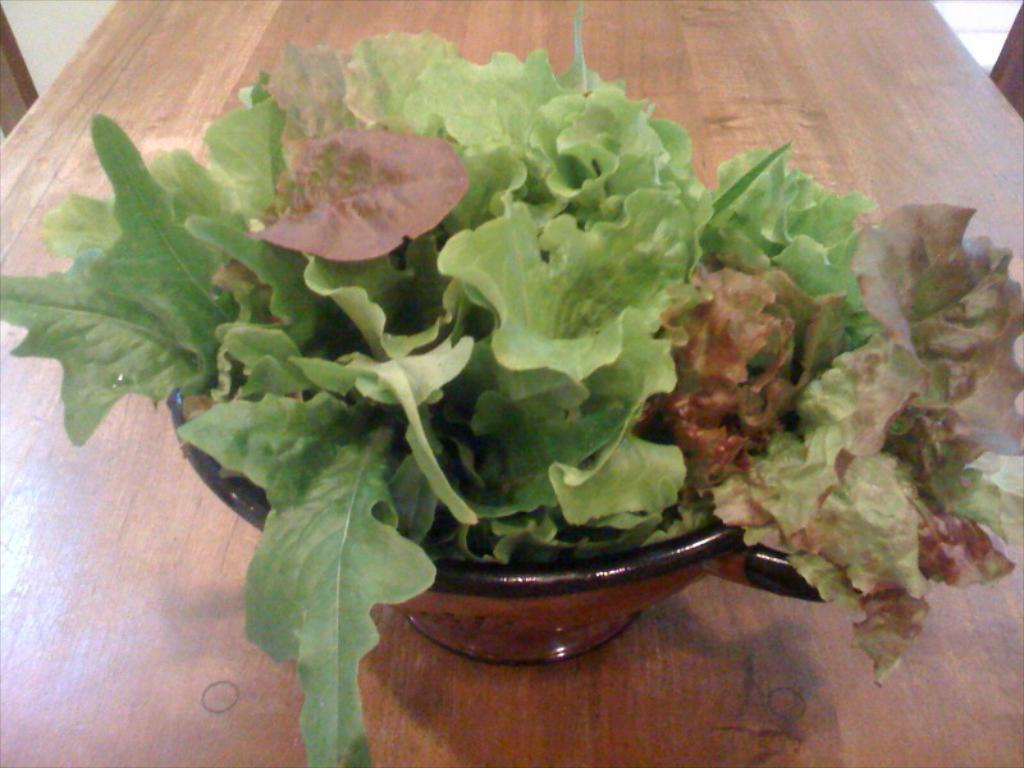What object is present in the image that contains plants? There is a flower pot in the image. What color are the leaves on the plant in the flower pot? The flower pot has green leaves. On what surface is the flower pot placed? The flower pot is placed on a brown wooden table. How many geese are visible in the image? There are no geese present in the image. What type of potato is being used as a centerpiece on the table? There is no potato present in the image; it features a flower pot with green leaves. 